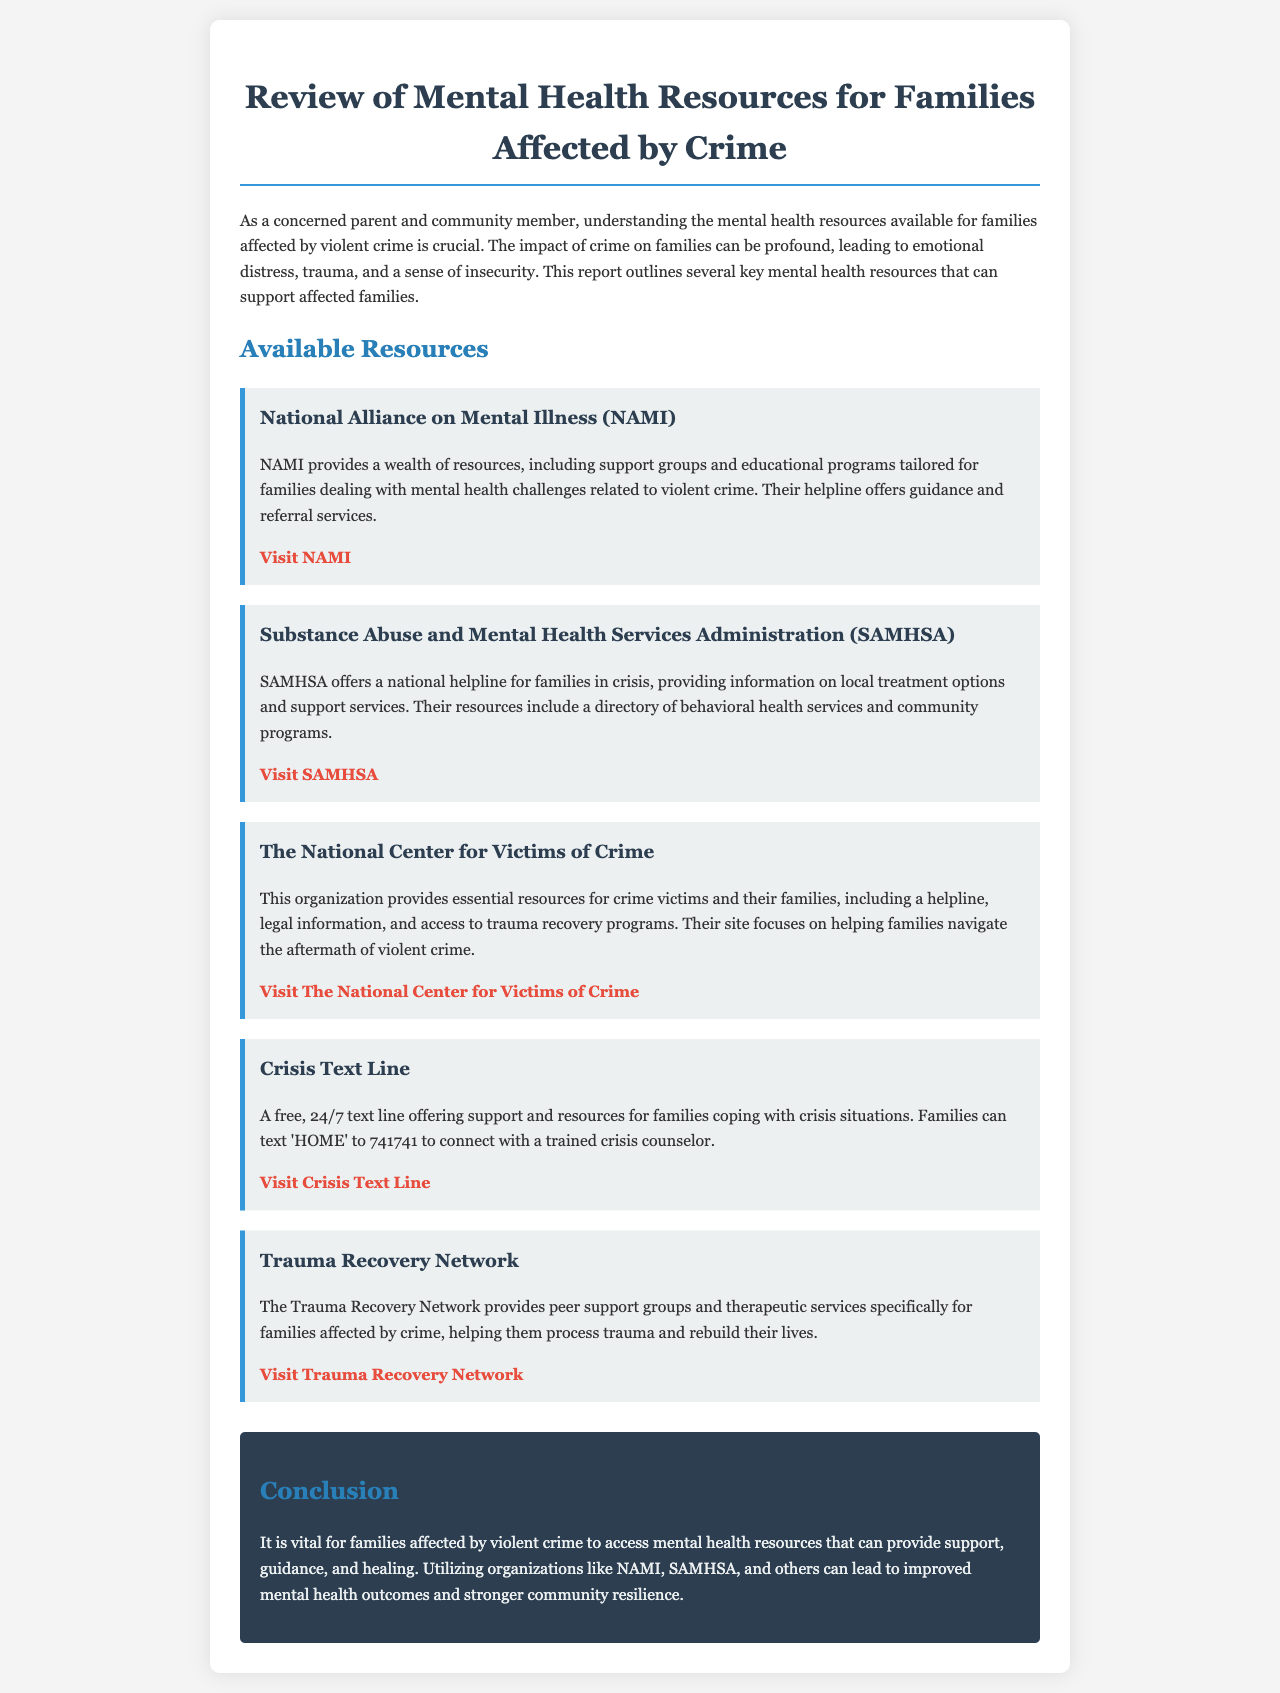What organization provides support groups and educational programs for families? NAMI is mentioned in the document as providing support groups and educational programs for families dealing with mental health challenges.
Answer: NAMI What is the helpline number for the Crisis Text Line? The document states that families can text 'HOME' to connect with a trained crisis counselor but does not provide a numerical helpline.
Answer: 741741 Name one resource provided by SAMHSA. SAMHSA provides information on local treatment options, which is a specific resource mentioned in the document.
Answer: local treatment options What service does The National Center for Victims of Crime offer? The National Center for Victims of Crime provides a helpline among other services to support crime victims and their families.
Answer: helpline How does the Trauma Recovery Network assist families? The document states that the Trauma Recovery Network provides peer support groups and therapeutic services for families affected by crime to help them process trauma.
Answer: peer support groups What is the main conclusion of the report? The conclusion emphasizes the importance of accessing mental health resources for families affected by violent crime to promote healing and resilience.
Answer: access mental health resources What is the URL for the Crisis Text Line? The document provides specific links, including the one for the Crisis Text Line, which can be found in the resource section.
Answer: https://www.crisistextline.org List one organization mentioned that focuses on trauma recovery. The document explicitly names the Trauma Recovery Network as an organization focused on trauma recovery for families affected by crime.
Answer: Trauma Recovery Network 